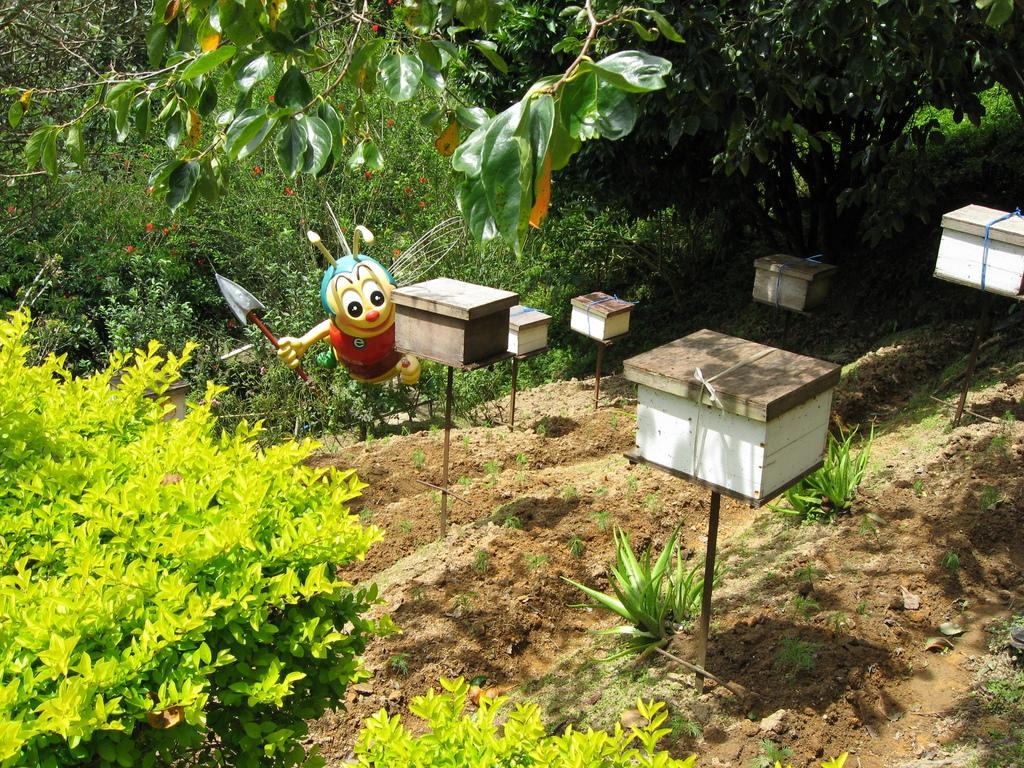What can be seen on the stands in the image? There are boxes on the stands in the image. What type of vegetation is present on the ground in the image? There are plants on the ground in the image. How many trees are visible in the image? There are many trees in the image. What kind of statue is present in the image? There is a honey bee statue in the image. What type of corn can be seen growing in the image? There is no corn present in the image; it features stands with boxes, plants on the ground, many trees, and a honey bee statue. What rhythm is being played by the honey bee statue in the image? The honey bee statue is a statue and does not play any rhythm in the image. 